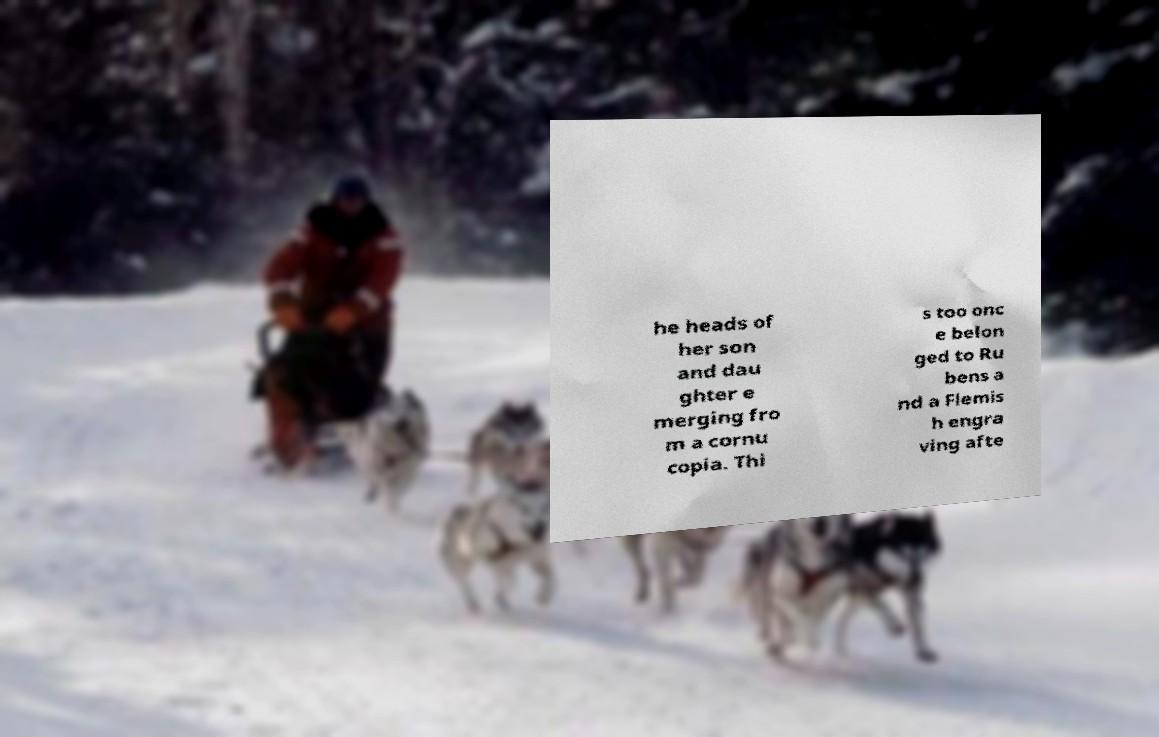For documentation purposes, I need the text within this image transcribed. Could you provide that? he heads of her son and dau ghter e merging fro m a cornu copia. Thi s too onc e belon ged to Ru bens a nd a Flemis h engra ving afte 